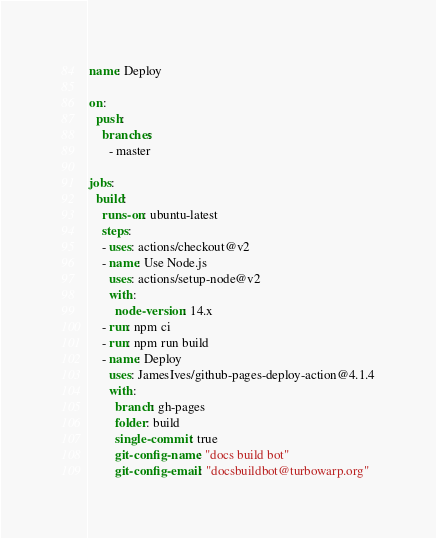<code> <loc_0><loc_0><loc_500><loc_500><_YAML_>name: Deploy

on:
  push:
    branches:
      - master

jobs:
  build:
    runs-on: ubuntu-latest
    steps:
    - uses: actions/checkout@v2
    - name: Use Node.js
      uses: actions/setup-node@v2
      with:
        node-version: 14.x
    - run: npm ci
    - run: npm run build
    - name: Deploy
      uses: JamesIves/github-pages-deploy-action@4.1.4
      with:
        branch: gh-pages
        folder: build
        single-commit: true
        git-config-name: "docs build bot"
        git-config-email: "docsbuildbot@turbowarp.org"
</code> 